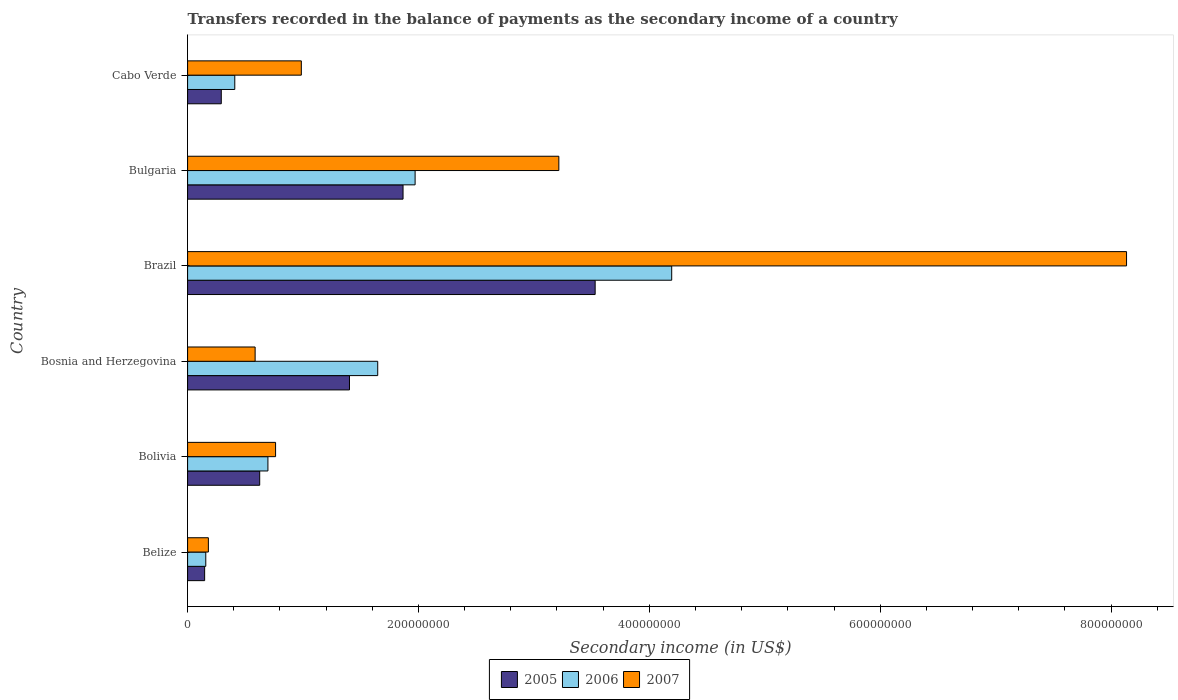How many groups of bars are there?
Keep it short and to the point. 6. How many bars are there on the 2nd tick from the top?
Make the answer very short. 3. How many bars are there on the 5th tick from the bottom?
Make the answer very short. 3. What is the label of the 4th group of bars from the top?
Keep it short and to the point. Bosnia and Herzegovina. In how many cases, is the number of bars for a given country not equal to the number of legend labels?
Give a very brief answer. 0. What is the secondary income of in 2005 in Bosnia and Herzegovina?
Provide a succinct answer. 1.40e+08. Across all countries, what is the maximum secondary income of in 2005?
Offer a terse response. 3.53e+08. Across all countries, what is the minimum secondary income of in 2005?
Make the answer very short. 1.48e+07. In which country was the secondary income of in 2006 maximum?
Offer a very short reply. Brazil. In which country was the secondary income of in 2007 minimum?
Offer a terse response. Belize. What is the total secondary income of in 2005 in the graph?
Your answer should be compact. 7.86e+08. What is the difference between the secondary income of in 2005 in Belize and that in Bolivia?
Provide a short and direct response. -4.77e+07. What is the difference between the secondary income of in 2005 in Bolivia and the secondary income of in 2006 in Bosnia and Herzegovina?
Provide a succinct answer. -1.02e+08. What is the average secondary income of in 2007 per country?
Make the answer very short. 2.31e+08. What is the difference between the secondary income of in 2005 and secondary income of in 2007 in Brazil?
Your answer should be compact. -4.60e+08. What is the ratio of the secondary income of in 2005 in Belize to that in Cabo Verde?
Offer a very short reply. 0.51. Is the difference between the secondary income of in 2005 in Bosnia and Herzegovina and Bulgaria greater than the difference between the secondary income of in 2007 in Bosnia and Herzegovina and Bulgaria?
Ensure brevity in your answer.  Yes. What is the difference between the highest and the second highest secondary income of in 2005?
Keep it short and to the point. 1.66e+08. What is the difference between the highest and the lowest secondary income of in 2007?
Your answer should be very brief. 7.95e+08. What does the 3rd bar from the bottom in Belize represents?
Your response must be concise. 2007. Is it the case that in every country, the sum of the secondary income of in 2007 and secondary income of in 2005 is greater than the secondary income of in 2006?
Your response must be concise. Yes. What is the difference between two consecutive major ticks on the X-axis?
Your answer should be very brief. 2.00e+08. Does the graph contain any zero values?
Give a very brief answer. No. Where does the legend appear in the graph?
Ensure brevity in your answer.  Bottom center. What is the title of the graph?
Give a very brief answer. Transfers recorded in the balance of payments as the secondary income of a country. Does "1971" appear as one of the legend labels in the graph?
Provide a short and direct response. No. What is the label or title of the X-axis?
Provide a succinct answer. Secondary income (in US$). What is the Secondary income (in US$) of 2005 in Belize?
Your response must be concise. 1.48e+07. What is the Secondary income (in US$) in 2006 in Belize?
Ensure brevity in your answer.  1.58e+07. What is the Secondary income (in US$) in 2007 in Belize?
Offer a very short reply. 1.80e+07. What is the Secondary income (in US$) in 2005 in Bolivia?
Make the answer very short. 6.25e+07. What is the Secondary income (in US$) of 2006 in Bolivia?
Make the answer very short. 6.96e+07. What is the Secondary income (in US$) in 2007 in Bolivia?
Provide a short and direct response. 7.62e+07. What is the Secondary income (in US$) of 2005 in Bosnia and Herzegovina?
Give a very brief answer. 1.40e+08. What is the Secondary income (in US$) in 2006 in Bosnia and Herzegovina?
Give a very brief answer. 1.65e+08. What is the Secondary income (in US$) in 2007 in Bosnia and Herzegovina?
Your answer should be very brief. 5.85e+07. What is the Secondary income (in US$) of 2005 in Brazil?
Provide a succinct answer. 3.53e+08. What is the Secondary income (in US$) of 2006 in Brazil?
Your answer should be very brief. 4.19e+08. What is the Secondary income (in US$) of 2007 in Brazil?
Your response must be concise. 8.13e+08. What is the Secondary income (in US$) in 2005 in Bulgaria?
Offer a very short reply. 1.87e+08. What is the Secondary income (in US$) of 2006 in Bulgaria?
Provide a short and direct response. 1.97e+08. What is the Secondary income (in US$) of 2007 in Bulgaria?
Provide a short and direct response. 3.22e+08. What is the Secondary income (in US$) in 2005 in Cabo Verde?
Your response must be concise. 2.92e+07. What is the Secondary income (in US$) of 2006 in Cabo Verde?
Make the answer very short. 4.09e+07. What is the Secondary income (in US$) of 2007 in Cabo Verde?
Offer a terse response. 9.85e+07. Across all countries, what is the maximum Secondary income (in US$) of 2005?
Give a very brief answer. 3.53e+08. Across all countries, what is the maximum Secondary income (in US$) of 2006?
Ensure brevity in your answer.  4.19e+08. Across all countries, what is the maximum Secondary income (in US$) in 2007?
Provide a short and direct response. 8.13e+08. Across all countries, what is the minimum Secondary income (in US$) of 2005?
Make the answer very short. 1.48e+07. Across all countries, what is the minimum Secondary income (in US$) of 2006?
Provide a succinct answer. 1.58e+07. Across all countries, what is the minimum Secondary income (in US$) in 2007?
Your response must be concise. 1.80e+07. What is the total Secondary income (in US$) in 2005 in the graph?
Offer a very short reply. 7.86e+08. What is the total Secondary income (in US$) in 2006 in the graph?
Your answer should be compact. 9.07e+08. What is the total Secondary income (in US$) of 2007 in the graph?
Your response must be concise. 1.39e+09. What is the difference between the Secondary income (in US$) in 2005 in Belize and that in Bolivia?
Make the answer very short. -4.77e+07. What is the difference between the Secondary income (in US$) of 2006 in Belize and that in Bolivia?
Ensure brevity in your answer.  -5.38e+07. What is the difference between the Secondary income (in US$) in 2007 in Belize and that in Bolivia?
Make the answer very short. -5.82e+07. What is the difference between the Secondary income (in US$) in 2005 in Belize and that in Bosnia and Herzegovina?
Your answer should be very brief. -1.25e+08. What is the difference between the Secondary income (in US$) in 2006 in Belize and that in Bosnia and Herzegovina?
Offer a very short reply. -1.49e+08. What is the difference between the Secondary income (in US$) in 2007 in Belize and that in Bosnia and Herzegovina?
Your answer should be compact. -4.05e+07. What is the difference between the Secondary income (in US$) of 2005 in Belize and that in Brazil?
Ensure brevity in your answer.  -3.38e+08. What is the difference between the Secondary income (in US$) of 2006 in Belize and that in Brazil?
Your response must be concise. -4.04e+08. What is the difference between the Secondary income (in US$) of 2007 in Belize and that in Brazil?
Provide a succinct answer. -7.95e+08. What is the difference between the Secondary income (in US$) in 2005 in Belize and that in Bulgaria?
Make the answer very short. -1.72e+08. What is the difference between the Secondary income (in US$) of 2006 in Belize and that in Bulgaria?
Offer a terse response. -1.81e+08. What is the difference between the Secondary income (in US$) in 2007 in Belize and that in Bulgaria?
Your answer should be very brief. -3.04e+08. What is the difference between the Secondary income (in US$) of 2005 in Belize and that in Cabo Verde?
Provide a succinct answer. -1.44e+07. What is the difference between the Secondary income (in US$) of 2006 in Belize and that in Cabo Verde?
Offer a very short reply. -2.51e+07. What is the difference between the Secondary income (in US$) in 2007 in Belize and that in Cabo Verde?
Your response must be concise. -8.05e+07. What is the difference between the Secondary income (in US$) in 2005 in Bolivia and that in Bosnia and Herzegovina?
Your answer should be very brief. -7.78e+07. What is the difference between the Secondary income (in US$) in 2006 in Bolivia and that in Bosnia and Herzegovina?
Your answer should be very brief. -9.51e+07. What is the difference between the Secondary income (in US$) in 2007 in Bolivia and that in Bosnia and Herzegovina?
Keep it short and to the point. 1.77e+07. What is the difference between the Secondary income (in US$) of 2005 in Bolivia and that in Brazil?
Your answer should be very brief. -2.91e+08. What is the difference between the Secondary income (in US$) of 2006 in Bolivia and that in Brazil?
Your response must be concise. -3.50e+08. What is the difference between the Secondary income (in US$) of 2007 in Bolivia and that in Brazil?
Your response must be concise. -7.37e+08. What is the difference between the Secondary income (in US$) in 2005 in Bolivia and that in Bulgaria?
Your response must be concise. -1.24e+08. What is the difference between the Secondary income (in US$) in 2006 in Bolivia and that in Bulgaria?
Your response must be concise. -1.28e+08. What is the difference between the Secondary income (in US$) of 2007 in Bolivia and that in Bulgaria?
Your response must be concise. -2.45e+08. What is the difference between the Secondary income (in US$) of 2005 in Bolivia and that in Cabo Verde?
Provide a succinct answer. 3.33e+07. What is the difference between the Secondary income (in US$) of 2006 in Bolivia and that in Cabo Verde?
Provide a succinct answer. 2.87e+07. What is the difference between the Secondary income (in US$) of 2007 in Bolivia and that in Cabo Verde?
Your answer should be compact. -2.23e+07. What is the difference between the Secondary income (in US$) in 2005 in Bosnia and Herzegovina and that in Brazil?
Keep it short and to the point. -2.13e+08. What is the difference between the Secondary income (in US$) of 2006 in Bosnia and Herzegovina and that in Brazil?
Keep it short and to the point. -2.55e+08. What is the difference between the Secondary income (in US$) in 2007 in Bosnia and Herzegovina and that in Brazil?
Make the answer very short. -7.55e+08. What is the difference between the Secondary income (in US$) in 2005 in Bosnia and Herzegovina and that in Bulgaria?
Your answer should be compact. -4.64e+07. What is the difference between the Secondary income (in US$) of 2006 in Bosnia and Herzegovina and that in Bulgaria?
Give a very brief answer. -3.24e+07. What is the difference between the Secondary income (in US$) of 2007 in Bosnia and Herzegovina and that in Bulgaria?
Your answer should be compact. -2.63e+08. What is the difference between the Secondary income (in US$) in 2005 in Bosnia and Herzegovina and that in Cabo Verde?
Provide a short and direct response. 1.11e+08. What is the difference between the Secondary income (in US$) in 2006 in Bosnia and Herzegovina and that in Cabo Verde?
Ensure brevity in your answer.  1.24e+08. What is the difference between the Secondary income (in US$) in 2007 in Bosnia and Herzegovina and that in Cabo Verde?
Provide a short and direct response. -4.00e+07. What is the difference between the Secondary income (in US$) in 2005 in Brazil and that in Bulgaria?
Offer a terse response. 1.66e+08. What is the difference between the Secondary income (in US$) in 2006 in Brazil and that in Bulgaria?
Make the answer very short. 2.22e+08. What is the difference between the Secondary income (in US$) of 2007 in Brazil and that in Bulgaria?
Your response must be concise. 4.92e+08. What is the difference between the Secondary income (in US$) in 2005 in Brazil and that in Cabo Verde?
Your answer should be compact. 3.24e+08. What is the difference between the Secondary income (in US$) in 2006 in Brazil and that in Cabo Verde?
Your answer should be compact. 3.79e+08. What is the difference between the Secondary income (in US$) in 2007 in Brazil and that in Cabo Verde?
Provide a succinct answer. 7.15e+08. What is the difference between the Secondary income (in US$) in 2005 in Bulgaria and that in Cabo Verde?
Offer a terse response. 1.57e+08. What is the difference between the Secondary income (in US$) in 2006 in Bulgaria and that in Cabo Verde?
Keep it short and to the point. 1.56e+08. What is the difference between the Secondary income (in US$) of 2007 in Bulgaria and that in Cabo Verde?
Ensure brevity in your answer.  2.23e+08. What is the difference between the Secondary income (in US$) of 2005 in Belize and the Secondary income (in US$) of 2006 in Bolivia?
Provide a succinct answer. -5.48e+07. What is the difference between the Secondary income (in US$) of 2005 in Belize and the Secondary income (in US$) of 2007 in Bolivia?
Offer a terse response. -6.14e+07. What is the difference between the Secondary income (in US$) of 2006 in Belize and the Secondary income (in US$) of 2007 in Bolivia?
Make the answer very short. -6.05e+07. What is the difference between the Secondary income (in US$) of 2005 in Belize and the Secondary income (in US$) of 2006 in Bosnia and Herzegovina?
Your response must be concise. -1.50e+08. What is the difference between the Secondary income (in US$) of 2005 in Belize and the Secondary income (in US$) of 2007 in Bosnia and Herzegovina?
Your answer should be compact. -4.37e+07. What is the difference between the Secondary income (in US$) of 2006 in Belize and the Secondary income (in US$) of 2007 in Bosnia and Herzegovina?
Keep it short and to the point. -4.28e+07. What is the difference between the Secondary income (in US$) in 2005 in Belize and the Secondary income (in US$) in 2006 in Brazil?
Your answer should be compact. -4.05e+08. What is the difference between the Secondary income (in US$) in 2005 in Belize and the Secondary income (in US$) in 2007 in Brazil?
Make the answer very short. -7.99e+08. What is the difference between the Secondary income (in US$) of 2006 in Belize and the Secondary income (in US$) of 2007 in Brazil?
Your response must be concise. -7.98e+08. What is the difference between the Secondary income (in US$) in 2005 in Belize and the Secondary income (in US$) in 2006 in Bulgaria?
Your response must be concise. -1.82e+08. What is the difference between the Secondary income (in US$) of 2005 in Belize and the Secondary income (in US$) of 2007 in Bulgaria?
Your answer should be very brief. -3.07e+08. What is the difference between the Secondary income (in US$) in 2006 in Belize and the Secondary income (in US$) in 2007 in Bulgaria?
Provide a short and direct response. -3.06e+08. What is the difference between the Secondary income (in US$) in 2005 in Belize and the Secondary income (in US$) in 2006 in Cabo Verde?
Give a very brief answer. -2.61e+07. What is the difference between the Secondary income (in US$) in 2005 in Belize and the Secondary income (in US$) in 2007 in Cabo Verde?
Ensure brevity in your answer.  -8.38e+07. What is the difference between the Secondary income (in US$) of 2006 in Belize and the Secondary income (in US$) of 2007 in Cabo Verde?
Offer a very short reply. -8.28e+07. What is the difference between the Secondary income (in US$) of 2005 in Bolivia and the Secondary income (in US$) of 2006 in Bosnia and Herzegovina?
Make the answer very short. -1.02e+08. What is the difference between the Secondary income (in US$) in 2005 in Bolivia and the Secondary income (in US$) in 2007 in Bosnia and Herzegovina?
Your answer should be very brief. 3.96e+06. What is the difference between the Secondary income (in US$) of 2006 in Bolivia and the Secondary income (in US$) of 2007 in Bosnia and Herzegovina?
Make the answer very short. 1.11e+07. What is the difference between the Secondary income (in US$) in 2005 in Bolivia and the Secondary income (in US$) in 2006 in Brazil?
Your answer should be very brief. -3.57e+08. What is the difference between the Secondary income (in US$) of 2005 in Bolivia and the Secondary income (in US$) of 2007 in Brazil?
Give a very brief answer. -7.51e+08. What is the difference between the Secondary income (in US$) in 2006 in Bolivia and the Secondary income (in US$) in 2007 in Brazil?
Ensure brevity in your answer.  -7.44e+08. What is the difference between the Secondary income (in US$) of 2005 in Bolivia and the Secondary income (in US$) of 2006 in Bulgaria?
Provide a short and direct response. -1.35e+08. What is the difference between the Secondary income (in US$) of 2005 in Bolivia and the Secondary income (in US$) of 2007 in Bulgaria?
Keep it short and to the point. -2.59e+08. What is the difference between the Secondary income (in US$) of 2006 in Bolivia and the Secondary income (in US$) of 2007 in Bulgaria?
Ensure brevity in your answer.  -2.52e+08. What is the difference between the Secondary income (in US$) in 2005 in Bolivia and the Secondary income (in US$) in 2006 in Cabo Verde?
Provide a succinct answer. 2.16e+07. What is the difference between the Secondary income (in US$) of 2005 in Bolivia and the Secondary income (in US$) of 2007 in Cabo Verde?
Give a very brief answer. -3.61e+07. What is the difference between the Secondary income (in US$) of 2006 in Bolivia and the Secondary income (in US$) of 2007 in Cabo Verde?
Make the answer very short. -2.89e+07. What is the difference between the Secondary income (in US$) of 2005 in Bosnia and Herzegovina and the Secondary income (in US$) of 2006 in Brazil?
Your response must be concise. -2.79e+08. What is the difference between the Secondary income (in US$) in 2005 in Bosnia and Herzegovina and the Secondary income (in US$) in 2007 in Brazil?
Your response must be concise. -6.73e+08. What is the difference between the Secondary income (in US$) in 2006 in Bosnia and Herzegovina and the Secondary income (in US$) in 2007 in Brazil?
Give a very brief answer. -6.49e+08. What is the difference between the Secondary income (in US$) in 2005 in Bosnia and Herzegovina and the Secondary income (in US$) in 2006 in Bulgaria?
Provide a succinct answer. -5.69e+07. What is the difference between the Secondary income (in US$) of 2005 in Bosnia and Herzegovina and the Secondary income (in US$) of 2007 in Bulgaria?
Ensure brevity in your answer.  -1.81e+08. What is the difference between the Secondary income (in US$) of 2006 in Bosnia and Herzegovina and the Secondary income (in US$) of 2007 in Bulgaria?
Provide a short and direct response. -1.57e+08. What is the difference between the Secondary income (in US$) of 2005 in Bosnia and Herzegovina and the Secondary income (in US$) of 2006 in Cabo Verde?
Ensure brevity in your answer.  9.94e+07. What is the difference between the Secondary income (in US$) in 2005 in Bosnia and Herzegovina and the Secondary income (in US$) in 2007 in Cabo Verde?
Provide a succinct answer. 4.17e+07. What is the difference between the Secondary income (in US$) in 2006 in Bosnia and Herzegovina and the Secondary income (in US$) in 2007 in Cabo Verde?
Your answer should be very brief. 6.62e+07. What is the difference between the Secondary income (in US$) in 2005 in Brazil and the Secondary income (in US$) in 2006 in Bulgaria?
Offer a terse response. 1.56e+08. What is the difference between the Secondary income (in US$) in 2005 in Brazil and the Secondary income (in US$) in 2007 in Bulgaria?
Provide a succinct answer. 3.15e+07. What is the difference between the Secondary income (in US$) in 2006 in Brazil and the Secondary income (in US$) in 2007 in Bulgaria?
Provide a succinct answer. 9.78e+07. What is the difference between the Secondary income (in US$) of 2005 in Brazil and the Secondary income (in US$) of 2006 in Cabo Verde?
Your answer should be very brief. 3.12e+08. What is the difference between the Secondary income (in US$) in 2005 in Brazil and the Secondary income (in US$) in 2007 in Cabo Verde?
Your answer should be compact. 2.55e+08. What is the difference between the Secondary income (in US$) in 2006 in Brazil and the Secondary income (in US$) in 2007 in Cabo Verde?
Ensure brevity in your answer.  3.21e+08. What is the difference between the Secondary income (in US$) of 2005 in Bulgaria and the Secondary income (in US$) of 2006 in Cabo Verde?
Keep it short and to the point. 1.46e+08. What is the difference between the Secondary income (in US$) of 2005 in Bulgaria and the Secondary income (in US$) of 2007 in Cabo Verde?
Give a very brief answer. 8.81e+07. What is the difference between the Secondary income (in US$) of 2006 in Bulgaria and the Secondary income (in US$) of 2007 in Cabo Verde?
Offer a terse response. 9.86e+07. What is the average Secondary income (in US$) of 2005 per country?
Offer a terse response. 1.31e+08. What is the average Secondary income (in US$) of 2006 per country?
Keep it short and to the point. 1.51e+08. What is the average Secondary income (in US$) in 2007 per country?
Provide a succinct answer. 2.31e+08. What is the difference between the Secondary income (in US$) of 2005 and Secondary income (in US$) of 2006 in Belize?
Your answer should be compact. -9.82e+05. What is the difference between the Secondary income (in US$) of 2005 and Secondary income (in US$) of 2007 in Belize?
Provide a short and direct response. -3.23e+06. What is the difference between the Secondary income (in US$) of 2006 and Secondary income (in US$) of 2007 in Belize?
Offer a very short reply. -2.25e+06. What is the difference between the Secondary income (in US$) in 2005 and Secondary income (in US$) in 2006 in Bolivia?
Provide a short and direct response. -7.13e+06. What is the difference between the Secondary income (in US$) of 2005 and Secondary income (in US$) of 2007 in Bolivia?
Give a very brief answer. -1.38e+07. What is the difference between the Secondary income (in US$) in 2006 and Secondary income (in US$) in 2007 in Bolivia?
Provide a short and direct response. -6.62e+06. What is the difference between the Secondary income (in US$) of 2005 and Secondary income (in US$) of 2006 in Bosnia and Herzegovina?
Keep it short and to the point. -2.45e+07. What is the difference between the Secondary income (in US$) of 2005 and Secondary income (in US$) of 2007 in Bosnia and Herzegovina?
Your answer should be compact. 8.17e+07. What is the difference between the Secondary income (in US$) of 2006 and Secondary income (in US$) of 2007 in Bosnia and Herzegovina?
Your answer should be very brief. 1.06e+08. What is the difference between the Secondary income (in US$) of 2005 and Secondary income (in US$) of 2006 in Brazil?
Your response must be concise. -6.63e+07. What is the difference between the Secondary income (in US$) of 2005 and Secondary income (in US$) of 2007 in Brazil?
Ensure brevity in your answer.  -4.60e+08. What is the difference between the Secondary income (in US$) in 2006 and Secondary income (in US$) in 2007 in Brazil?
Your answer should be very brief. -3.94e+08. What is the difference between the Secondary income (in US$) of 2005 and Secondary income (in US$) of 2006 in Bulgaria?
Provide a short and direct response. -1.05e+07. What is the difference between the Secondary income (in US$) of 2005 and Secondary income (in US$) of 2007 in Bulgaria?
Ensure brevity in your answer.  -1.35e+08. What is the difference between the Secondary income (in US$) in 2006 and Secondary income (in US$) in 2007 in Bulgaria?
Your answer should be very brief. -1.25e+08. What is the difference between the Secondary income (in US$) in 2005 and Secondary income (in US$) in 2006 in Cabo Verde?
Provide a short and direct response. -1.17e+07. What is the difference between the Secondary income (in US$) of 2005 and Secondary income (in US$) of 2007 in Cabo Verde?
Offer a very short reply. -6.94e+07. What is the difference between the Secondary income (in US$) of 2006 and Secondary income (in US$) of 2007 in Cabo Verde?
Your answer should be very brief. -5.77e+07. What is the ratio of the Secondary income (in US$) in 2005 in Belize to that in Bolivia?
Your response must be concise. 0.24. What is the ratio of the Secondary income (in US$) in 2006 in Belize to that in Bolivia?
Your answer should be compact. 0.23. What is the ratio of the Secondary income (in US$) in 2007 in Belize to that in Bolivia?
Offer a terse response. 0.24. What is the ratio of the Secondary income (in US$) in 2005 in Belize to that in Bosnia and Herzegovina?
Offer a terse response. 0.11. What is the ratio of the Secondary income (in US$) of 2006 in Belize to that in Bosnia and Herzegovina?
Offer a terse response. 0.1. What is the ratio of the Secondary income (in US$) of 2007 in Belize to that in Bosnia and Herzegovina?
Keep it short and to the point. 0.31. What is the ratio of the Secondary income (in US$) of 2005 in Belize to that in Brazil?
Keep it short and to the point. 0.04. What is the ratio of the Secondary income (in US$) in 2006 in Belize to that in Brazil?
Your response must be concise. 0.04. What is the ratio of the Secondary income (in US$) in 2007 in Belize to that in Brazil?
Make the answer very short. 0.02. What is the ratio of the Secondary income (in US$) of 2005 in Belize to that in Bulgaria?
Offer a terse response. 0.08. What is the ratio of the Secondary income (in US$) of 2006 in Belize to that in Bulgaria?
Provide a short and direct response. 0.08. What is the ratio of the Secondary income (in US$) in 2007 in Belize to that in Bulgaria?
Keep it short and to the point. 0.06. What is the ratio of the Secondary income (in US$) of 2005 in Belize to that in Cabo Verde?
Your response must be concise. 0.51. What is the ratio of the Secondary income (in US$) in 2006 in Belize to that in Cabo Verde?
Offer a terse response. 0.39. What is the ratio of the Secondary income (in US$) of 2007 in Belize to that in Cabo Verde?
Your answer should be compact. 0.18. What is the ratio of the Secondary income (in US$) of 2005 in Bolivia to that in Bosnia and Herzegovina?
Your answer should be compact. 0.45. What is the ratio of the Secondary income (in US$) in 2006 in Bolivia to that in Bosnia and Herzegovina?
Provide a succinct answer. 0.42. What is the ratio of the Secondary income (in US$) in 2007 in Bolivia to that in Bosnia and Herzegovina?
Make the answer very short. 1.3. What is the ratio of the Secondary income (in US$) of 2005 in Bolivia to that in Brazil?
Make the answer very short. 0.18. What is the ratio of the Secondary income (in US$) in 2006 in Bolivia to that in Brazil?
Offer a very short reply. 0.17. What is the ratio of the Secondary income (in US$) of 2007 in Bolivia to that in Brazil?
Provide a succinct answer. 0.09. What is the ratio of the Secondary income (in US$) in 2005 in Bolivia to that in Bulgaria?
Give a very brief answer. 0.33. What is the ratio of the Secondary income (in US$) in 2006 in Bolivia to that in Bulgaria?
Offer a very short reply. 0.35. What is the ratio of the Secondary income (in US$) of 2007 in Bolivia to that in Bulgaria?
Your answer should be very brief. 0.24. What is the ratio of the Secondary income (in US$) of 2005 in Bolivia to that in Cabo Verde?
Make the answer very short. 2.14. What is the ratio of the Secondary income (in US$) of 2006 in Bolivia to that in Cabo Verde?
Keep it short and to the point. 1.7. What is the ratio of the Secondary income (in US$) in 2007 in Bolivia to that in Cabo Verde?
Offer a terse response. 0.77. What is the ratio of the Secondary income (in US$) in 2005 in Bosnia and Herzegovina to that in Brazil?
Give a very brief answer. 0.4. What is the ratio of the Secondary income (in US$) of 2006 in Bosnia and Herzegovina to that in Brazil?
Provide a succinct answer. 0.39. What is the ratio of the Secondary income (in US$) of 2007 in Bosnia and Herzegovina to that in Brazil?
Your answer should be very brief. 0.07. What is the ratio of the Secondary income (in US$) of 2005 in Bosnia and Herzegovina to that in Bulgaria?
Ensure brevity in your answer.  0.75. What is the ratio of the Secondary income (in US$) of 2006 in Bosnia and Herzegovina to that in Bulgaria?
Your response must be concise. 0.84. What is the ratio of the Secondary income (in US$) of 2007 in Bosnia and Herzegovina to that in Bulgaria?
Your answer should be compact. 0.18. What is the ratio of the Secondary income (in US$) of 2005 in Bosnia and Herzegovina to that in Cabo Verde?
Your response must be concise. 4.81. What is the ratio of the Secondary income (in US$) of 2006 in Bosnia and Herzegovina to that in Cabo Verde?
Keep it short and to the point. 4.03. What is the ratio of the Secondary income (in US$) in 2007 in Bosnia and Herzegovina to that in Cabo Verde?
Make the answer very short. 0.59. What is the ratio of the Secondary income (in US$) in 2005 in Brazil to that in Bulgaria?
Provide a succinct answer. 1.89. What is the ratio of the Secondary income (in US$) of 2006 in Brazil to that in Bulgaria?
Offer a terse response. 2.13. What is the ratio of the Secondary income (in US$) of 2007 in Brazil to that in Bulgaria?
Your response must be concise. 2.53. What is the ratio of the Secondary income (in US$) in 2005 in Brazil to that in Cabo Verde?
Make the answer very short. 12.1. What is the ratio of the Secondary income (in US$) of 2006 in Brazil to that in Cabo Verde?
Offer a terse response. 10.26. What is the ratio of the Secondary income (in US$) of 2007 in Brazil to that in Cabo Verde?
Give a very brief answer. 8.26. What is the ratio of the Secondary income (in US$) in 2005 in Bulgaria to that in Cabo Verde?
Provide a short and direct response. 6.4. What is the ratio of the Secondary income (in US$) of 2006 in Bulgaria to that in Cabo Verde?
Your answer should be compact. 4.82. What is the ratio of the Secondary income (in US$) in 2007 in Bulgaria to that in Cabo Verde?
Offer a very short reply. 3.26. What is the difference between the highest and the second highest Secondary income (in US$) of 2005?
Your response must be concise. 1.66e+08. What is the difference between the highest and the second highest Secondary income (in US$) of 2006?
Your response must be concise. 2.22e+08. What is the difference between the highest and the second highest Secondary income (in US$) in 2007?
Provide a succinct answer. 4.92e+08. What is the difference between the highest and the lowest Secondary income (in US$) in 2005?
Your answer should be compact. 3.38e+08. What is the difference between the highest and the lowest Secondary income (in US$) in 2006?
Offer a very short reply. 4.04e+08. What is the difference between the highest and the lowest Secondary income (in US$) in 2007?
Ensure brevity in your answer.  7.95e+08. 